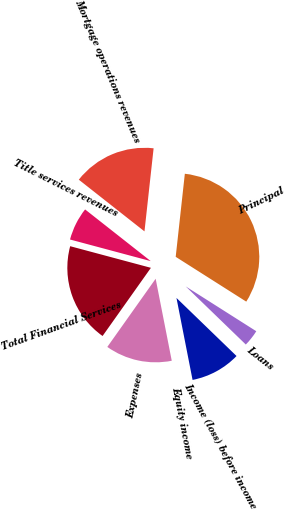Convert chart. <chart><loc_0><loc_0><loc_500><loc_500><pie_chart><fcel>Mortgage operations revenues<fcel>Title services revenues<fcel>Total Financial Services<fcel>Expenses<fcel>Equity income<fcel>Income (loss) before income<fcel>Loans<fcel>Principal<nl><fcel>16.13%<fcel>6.45%<fcel>19.35%<fcel>12.9%<fcel>0.0%<fcel>9.68%<fcel>3.23%<fcel>32.26%<nl></chart> 